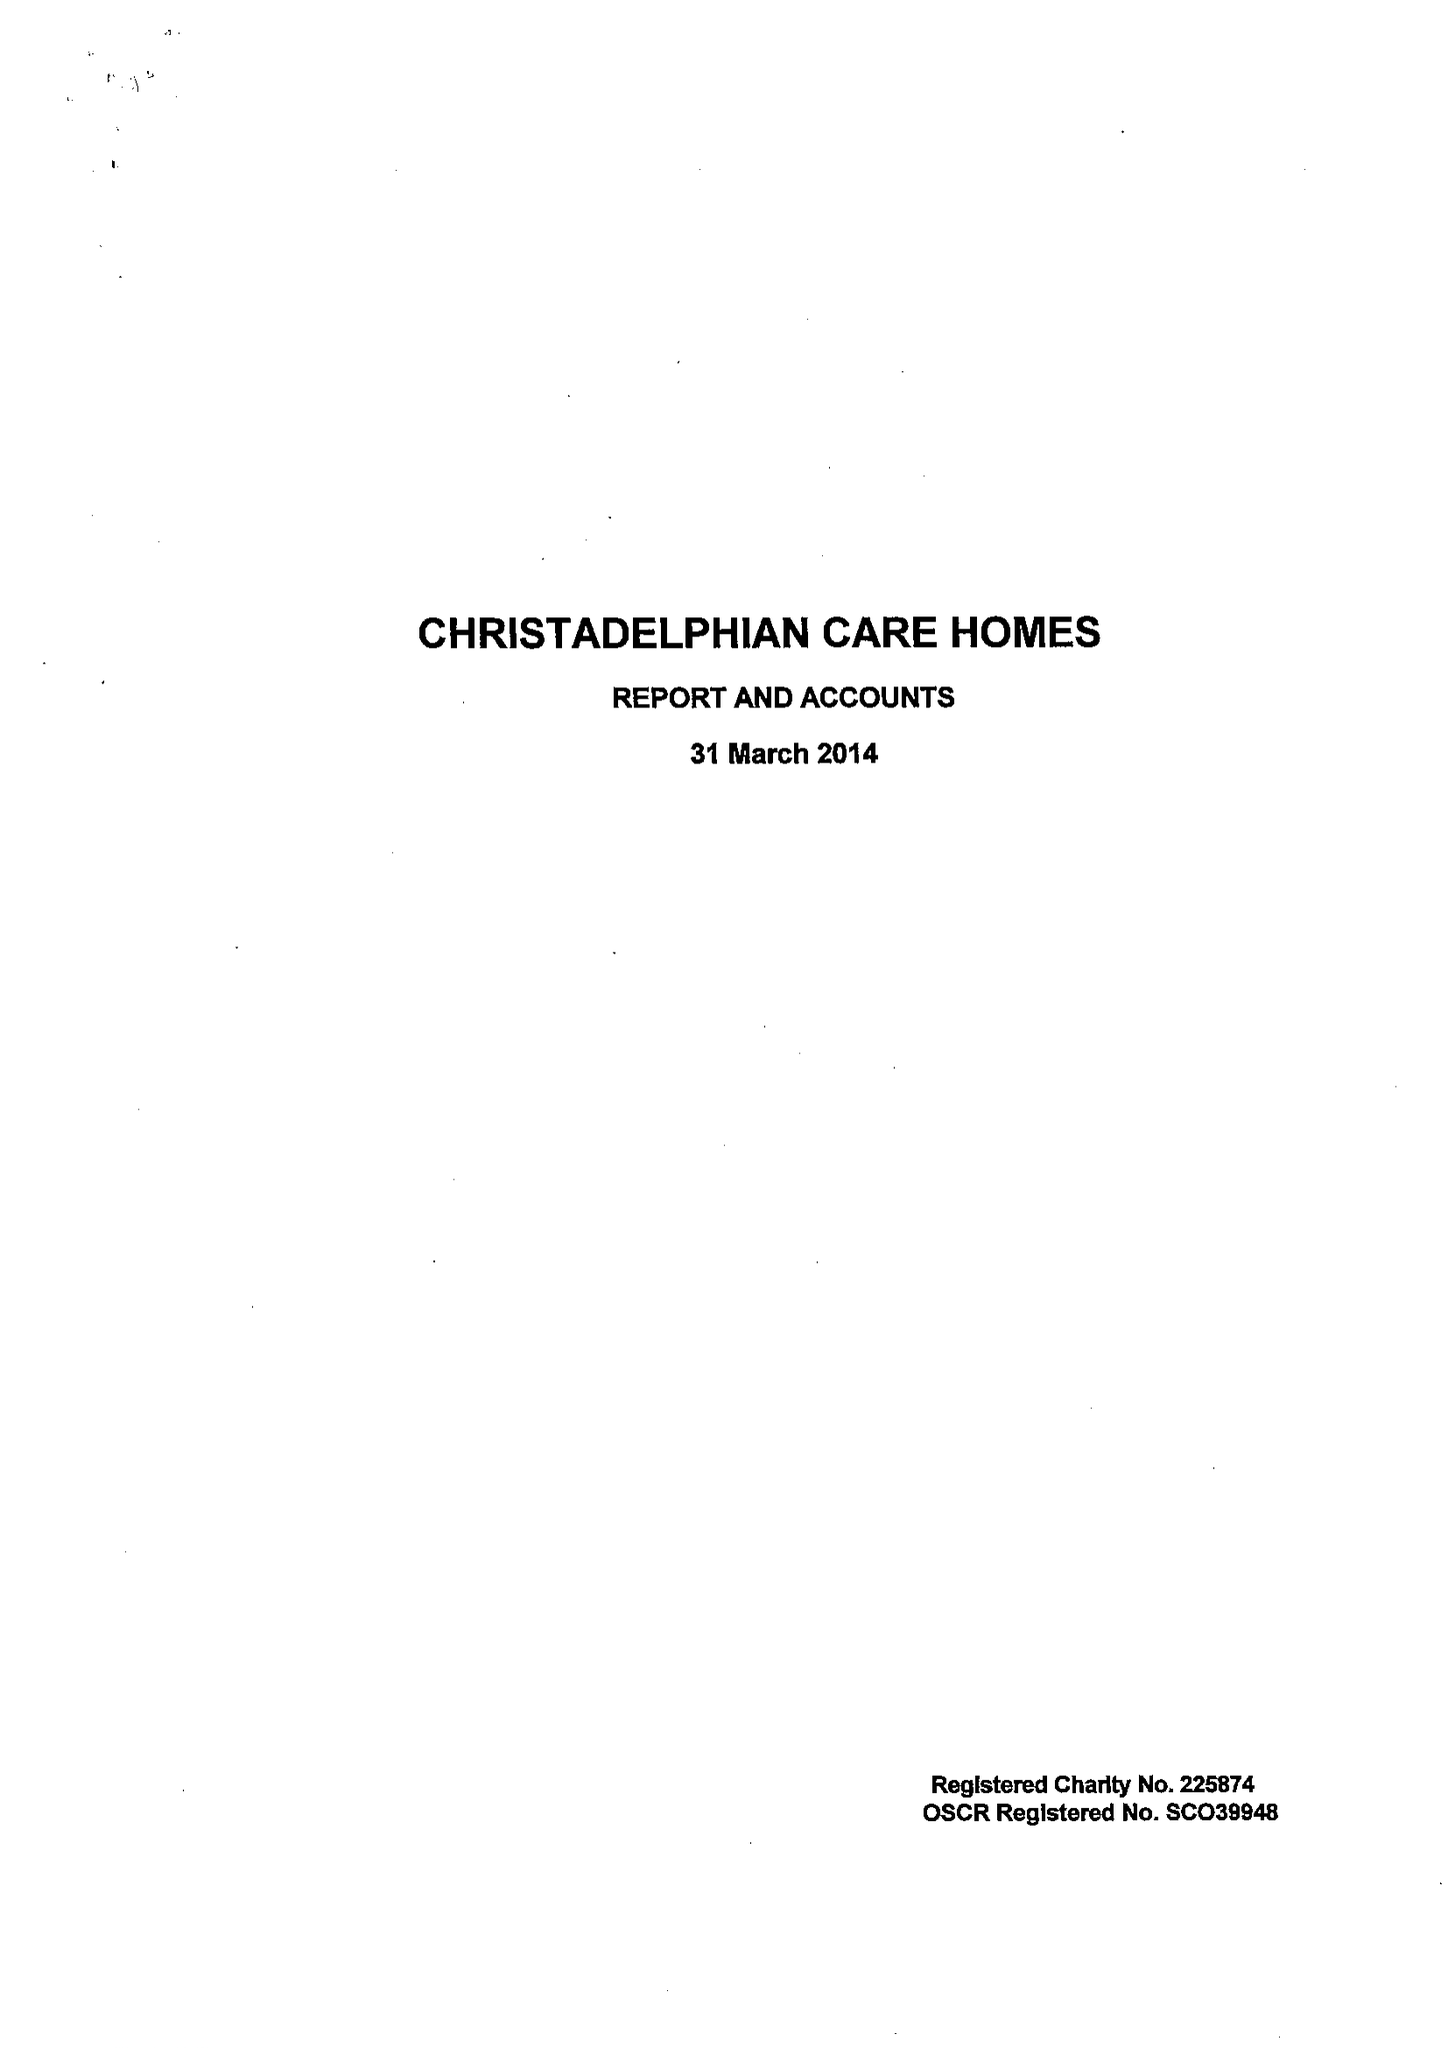What is the value for the spending_annually_in_british_pounds?
Answer the question using a single word or phrase. 8314683.00 